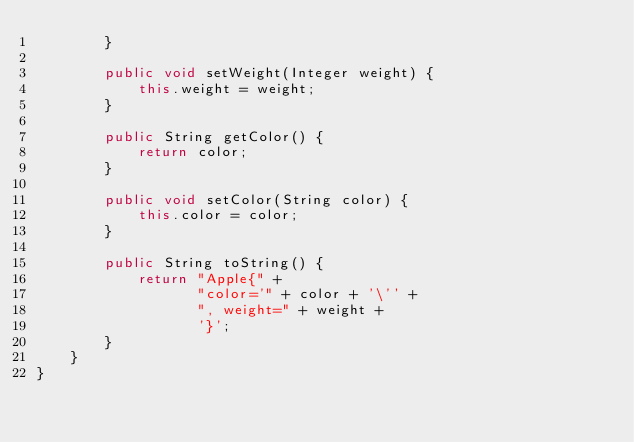<code> <loc_0><loc_0><loc_500><loc_500><_Java_>        }

        public void setWeight(Integer weight) {
            this.weight = weight;
        }

        public String getColor() {
            return color;
        }

        public void setColor(String color) {
            this.color = color;
        }

        public String toString() {
            return "Apple{" +
                   "color='" + color + '\'' +
                   ", weight=" + weight +
                   '}';
        }
    }
}
</code> 